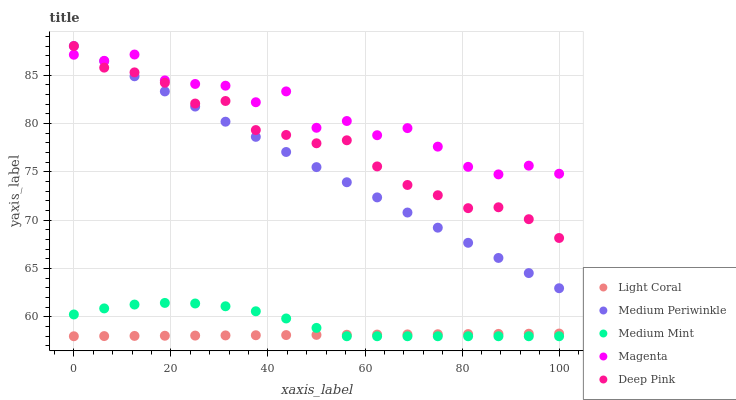Does Light Coral have the minimum area under the curve?
Answer yes or no. Yes. Does Magenta have the maximum area under the curve?
Answer yes or no. Yes. Does Medium Mint have the minimum area under the curve?
Answer yes or no. No. Does Medium Mint have the maximum area under the curve?
Answer yes or no. No. Is Light Coral the smoothest?
Answer yes or no. Yes. Is Magenta the roughest?
Answer yes or no. Yes. Is Medium Mint the smoothest?
Answer yes or no. No. Is Medium Mint the roughest?
Answer yes or no. No. Does Light Coral have the lowest value?
Answer yes or no. Yes. Does Magenta have the lowest value?
Answer yes or no. No. Does Medium Periwinkle have the highest value?
Answer yes or no. Yes. Does Medium Mint have the highest value?
Answer yes or no. No. Is Light Coral less than Magenta?
Answer yes or no. Yes. Is Medium Periwinkle greater than Medium Mint?
Answer yes or no. Yes. Does Deep Pink intersect Medium Periwinkle?
Answer yes or no. Yes. Is Deep Pink less than Medium Periwinkle?
Answer yes or no. No. Is Deep Pink greater than Medium Periwinkle?
Answer yes or no. No. Does Light Coral intersect Magenta?
Answer yes or no. No. 